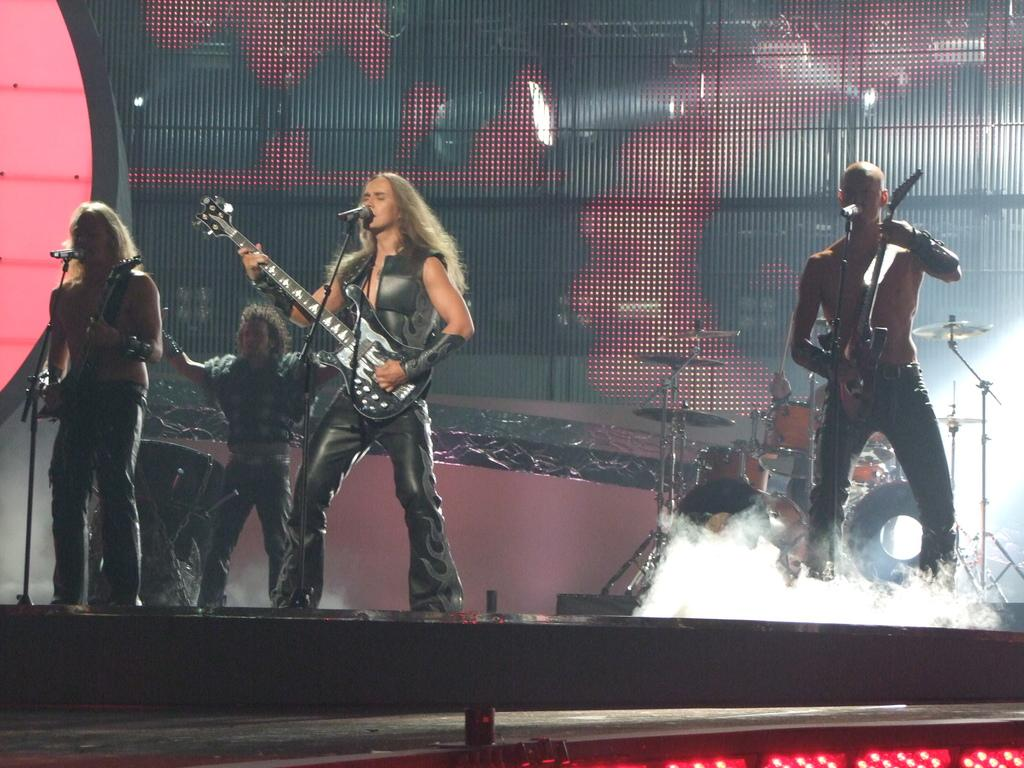Who is the main subject in the image? There is a person in the image. What is the person doing in the image? The person is standing and singing a song. What type of picture is hanging on the wall behind the person in the image? There is no mention of a picture hanging on the wall behind the person in the image. 